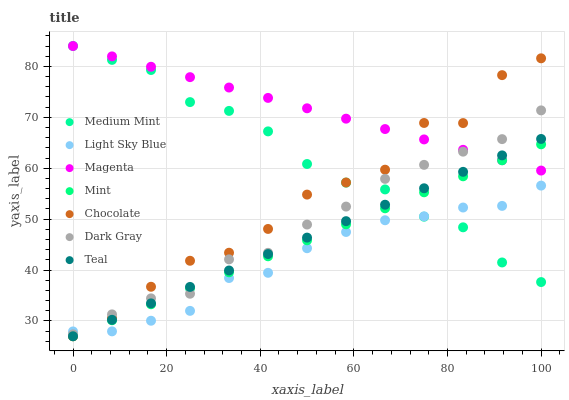Does Light Sky Blue have the minimum area under the curve?
Answer yes or no. Yes. Does Magenta have the maximum area under the curve?
Answer yes or no. Yes. Does Chocolate have the minimum area under the curve?
Answer yes or no. No. Does Chocolate have the maximum area under the curve?
Answer yes or no. No. Is Teal the smoothest?
Answer yes or no. Yes. Is Chocolate the roughest?
Answer yes or no. Yes. Is Dark Gray the smoothest?
Answer yes or no. No. Is Dark Gray the roughest?
Answer yes or no. No. Does Chocolate have the lowest value?
Answer yes or no. Yes. Does Dark Gray have the lowest value?
Answer yes or no. No. Does Magenta have the highest value?
Answer yes or no. Yes. Does Chocolate have the highest value?
Answer yes or no. No. Is Light Sky Blue less than Magenta?
Answer yes or no. Yes. Is Magenta greater than Light Sky Blue?
Answer yes or no. Yes. Does Teal intersect Chocolate?
Answer yes or no. Yes. Is Teal less than Chocolate?
Answer yes or no. No. Is Teal greater than Chocolate?
Answer yes or no. No. Does Light Sky Blue intersect Magenta?
Answer yes or no. No. 